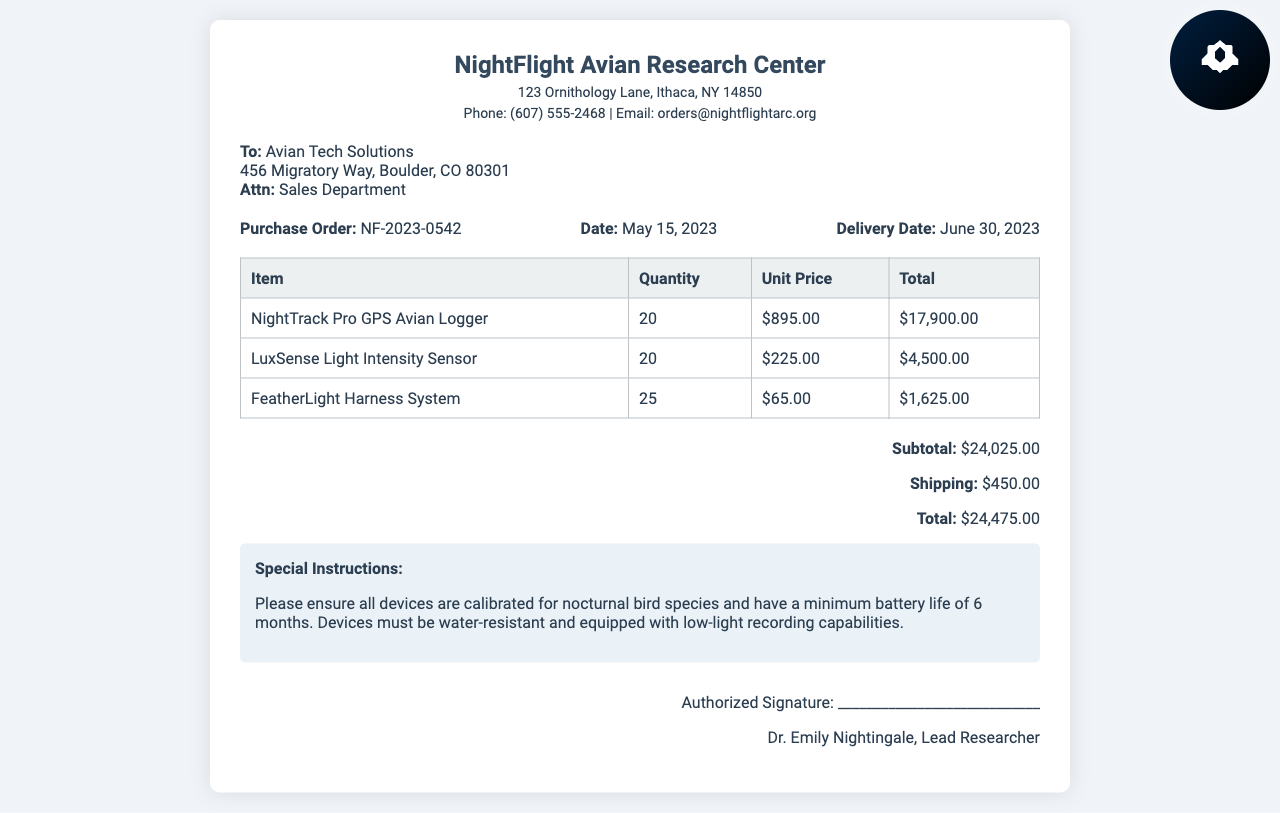what is the purchase order number? The purchase order number is explicitly stated in the document as NF-2023-0542.
Answer: NF-2023-0542 what is the date of the purchase order? The date of the purchase order is provided in the document as May 15, 2023.
Answer: May 15, 2023 who is the recipient of the purchase order? The recipient of the purchase order is clearly mentioned as Avian Tech Solutions.
Answer: Avian Tech Solutions how many NightTrack Pro GPS Avian Loggers are being ordered? The quantity of NightTrack Pro GPS Avian Loggers is specified in the order details as 20.
Answer: 20 what is the total amount due for this purchase order? The total amount due is summarized in the totals section of the document as $24,475.00.
Answer: $24,475.00 what special instructions are provided? The special instructions detail the specifications required for the devices, mainly calibration for nocturnal bird species.
Answer: Calibration for nocturnal bird species who signed the purchase order? The authorized signature at the bottom of the document is from Dr. Emily Nightingale.
Answer: Dr. Emily Nightingale what is the delivery date of the devices? The expected delivery date for the devices is listed as June 30, 2023.
Answer: June 30, 2023 how many LuxSense Light Intensity Sensors are included in the order? The order includes a total of 20 LuxSense Light Intensity Sensors as outlined in the itemized list.
Answer: 20 